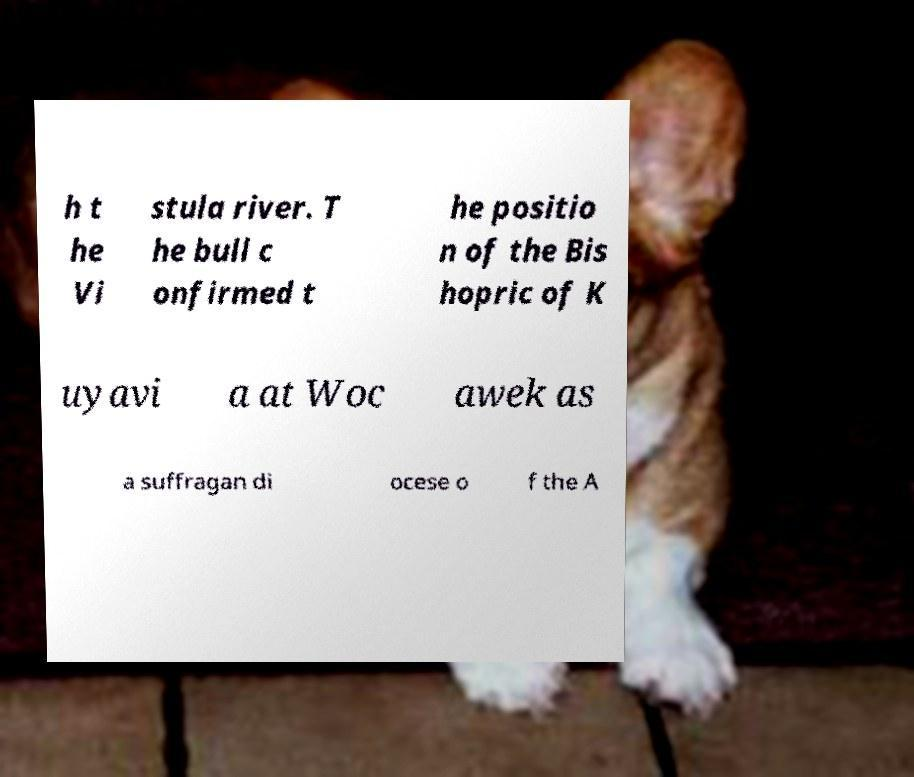There's text embedded in this image that I need extracted. Can you transcribe it verbatim? h t he Vi stula river. T he bull c onfirmed t he positio n of the Bis hopric of K uyavi a at Woc awek as a suffragan di ocese o f the A 